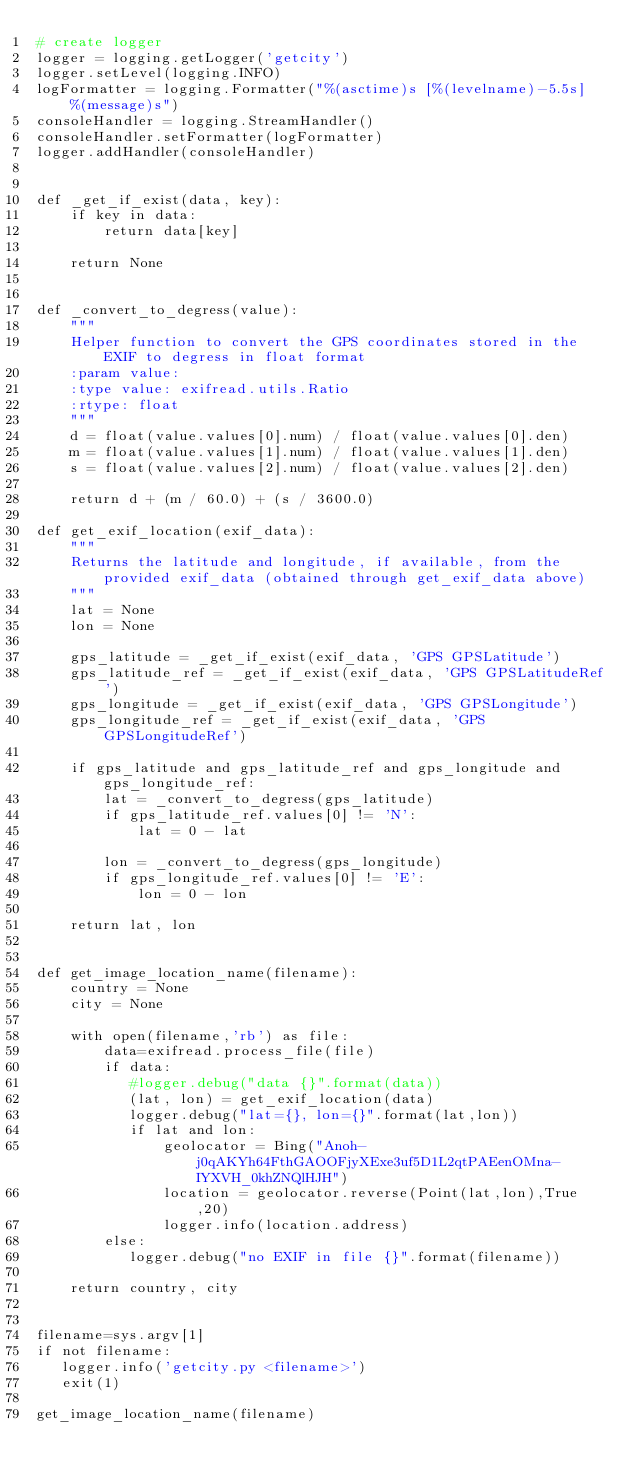<code> <loc_0><loc_0><loc_500><loc_500><_Python_># create logger
logger = logging.getLogger('getcity')
logger.setLevel(logging.INFO)
logFormatter = logging.Formatter("%(asctime)s [%(levelname)-5.5s]  %(message)s")
consoleHandler = logging.StreamHandler()
consoleHandler.setFormatter(logFormatter)
logger.addHandler(consoleHandler)


def _get_if_exist(data, key):
    if key in data:
        return data[key]

    return None


def _convert_to_degress(value):
    """
    Helper function to convert the GPS coordinates stored in the EXIF to degress in float format
    :param value:
    :type value: exifread.utils.Ratio
    :rtype: float
    """
    d = float(value.values[0].num) / float(value.values[0].den)
    m = float(value.values[1].num) / float(value.values[1].den)
    s = float(value.values[2].num) / float(value.values[2].den)

    return d + (m / 60.0) + (s / 3600.0)
    
def get_exif_location(exif_data):
    """
    Returns the latitude and longitude, if available, from the provided exif_data (obtained through get_exif_data above)
    """
    lat = None
    lon = None

    gps_latitude = _get_if_exist(exif_data, 'GPS GPSLatitude')
    gps_latitude_ref = _get_if_exist(exif_data, 'GPS GPSLatitudeRef')
    gps_longitude = _get_if_exist(exif_data, 'GPS GPSLongitude')
    gps_longitude_ref = _get_if_exist(exif_data, 'GPS GPSLongitudeRef')

    if gps_latitude and gps_latitude_ref and gps_longitude and gps_longitude_ref:
        lat = _convert_to_degress(gps_latitude)
        if gps_latitude_ref.values[0] != 'N':
            lat = 0 - lat

        lon = _convert_to_degress(gps_longitude)
        if gps_longitude_ref.values[0] != 'E':
            lon = 0 - lon

    return lat, lon


def get_image_location_name(filename):
    country = None
    city = None

    with open(filename,'rb') as file:
        data=exifread.process_file(file)
        if data:
           #logger.debug("data {}".format(data))
           (lat, lon) = get_exif_location(data)
           logger.debug("lat={}, lon={}".format(lat,lon))
           if lat and lon:
               geolocator = Bing("Anoh-j0qAKYh64FthGAOOFjyXExe3uf5D1L2qtPAEenOMna-IYXVH_0khZNQlHJH")
               location = geolocator.reverse(Point(lat,lon),True,20)
               logger.info(location.address)
        else:
           logger.debug("no EXIF in file {}".format(filename))

    return country, city


filename=sys.argv[1]
if not filename:
   logger.info('getcity.py <filename>')
   exit(1)

get_image_location_name(filename)
</code> 